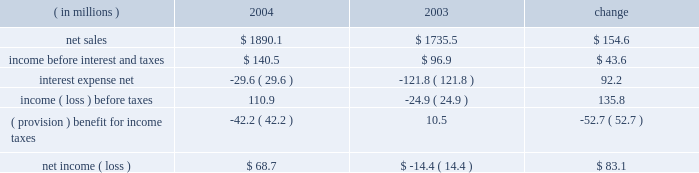Instruments at fair value and to recognize the effective and ineffective portions of the cash flow hedges .
( 2 ) for the year ended december 31 , 2000 , earnings available to common stockholders includes reductions of $ 2371 of preferred stock dividends and $ 16266 for the redemption of pca 2019s 123 20448% ( 20448 % ) preferred stock .
( 3 ) on october 13 , 2003 , pca announced its intention to begin paying a quarterly cash dividend of $ 0.15 per share , or $ 0.60 per share annually , on its common stock .
The first quarterly dividend of $ 0.15 per share was paid on january 15 , 2004 to shareholders of record as of december 15 , 2003 .
Pca did not declare any dividends on its common stock in 2000 - 2002 .
( 4 ) total long-term obligations include long-term debt , short-term debt and the current maturities of long-term debt .
Item 7 .
Management 2019s discussion and analysis of financial condition and results of operations the following discussion of historical results of operations and financial condition should be read in conjunction with the audited financial statements and the notes thereto which appear elsewhere in this report .
Overview on april 12 , 1999 , pca acquired the containerboard and corrugated products business of pactiv corporation ( the 201cgroup 201d ) , formerly known as tenneco packaging inc. , a wholly owned subsidiary of tenneco , inc .
The group operated prior to april 12 , 1999 as a division of pactiv , and not as a separate , stand-alone entity .
From its formation in january 1999 and through the closing of the acquisition on april 12 , 1999 , pca did not have any significant operations .
The april 12 , 1999 acquisition was accounted for using historical values for the contributed assets .
Purchase accounting was not applied because , under the applicable accounting guidance , a change of control was deemed not to have occurred as a result of the participating veto rights held by pactiv after the closing of the transactions under the terms of the stockholders agreement entered into in connection with the transactions .
Results of operations year ended december 31 , 2004 compared to year ended december 31 , 2003 the historical results of operations of pca for the years ended december , 31 2004 and 2003 are set forth the below : for the year ended december 31 , ( in millions ) 2004 2003 change .

Was interest expense net in 2004 greater than ( provision ) benefit for income taxes? 
Computations: (-29.6 > -42.2)
Answer: yes. 